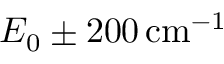<formula> <loc_0><loc_0><loc_500><loc_500>E _ { 0 } \pm 2 0 0 \, c m ^ { - 1 }</formula> 